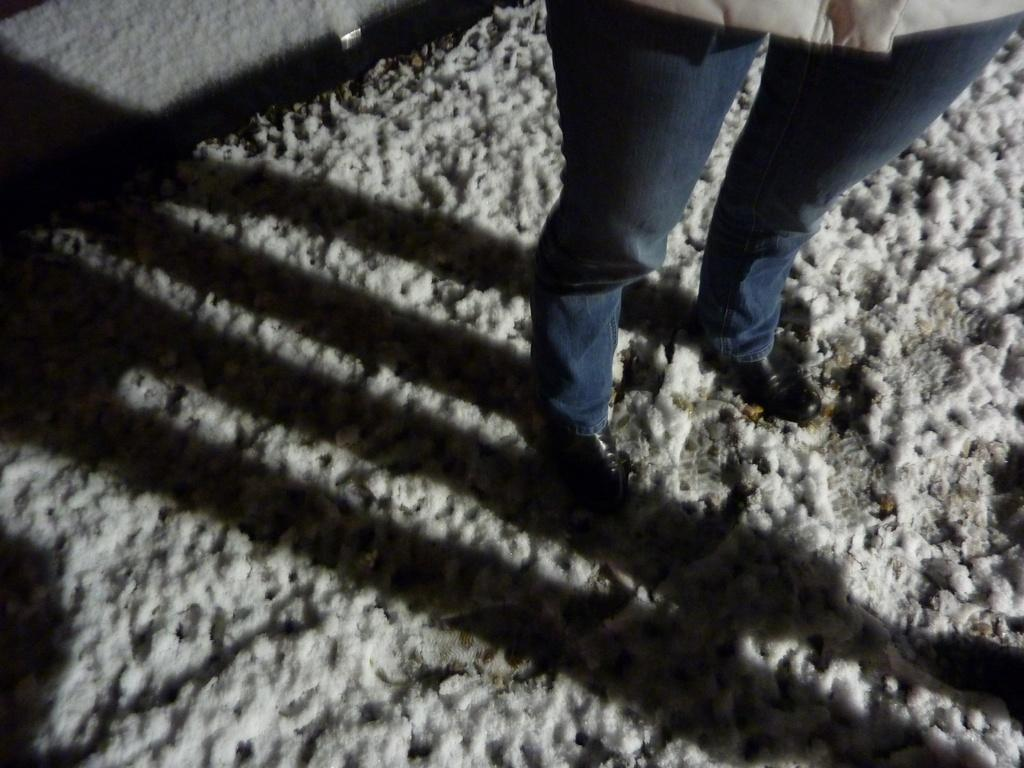Who is present in the image? There is a person in the image. What is the person standing on? The person is standing on a snow land. What decision did the person make regarding the hammer in the image? There is no hammer present in the image, so no decision regarding a hammer can be made. 